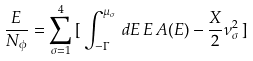<formula> <loc_0><loc_0><loc_500><loc_500>\frac { E } { N _ { \phi } } = \sum _ { \sigma = 1 } ^ { 4 } \, [ \, \int _ { - \Gamma } ^ { \mu _ { \sigma } } \, d E \, E \, A ( E ) - \frac { X } { 2 } \nu _ { \sigma } ^ { 2 } \, ]</formula> 